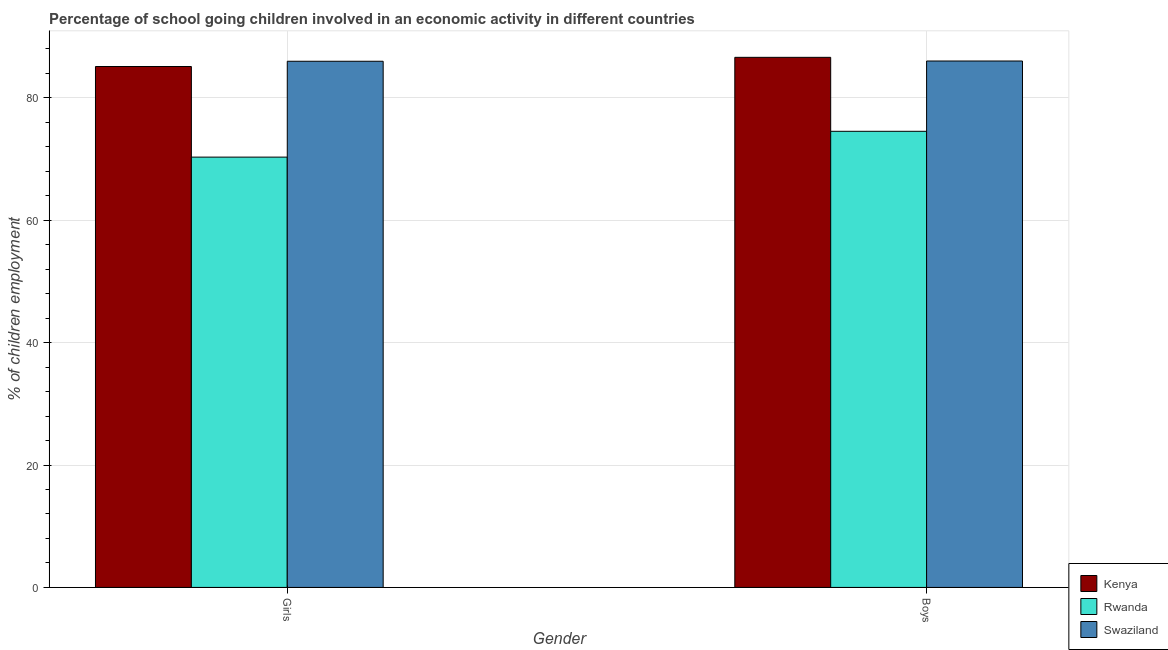How many different coloured bars are there?
Provide a succinct answer. 3. How many groups of bars are there?
Make the answer very short. 2. Are the number of bars per tick equal to the number of legend labels?
Offer a terse response. Yes. How many bars are there on the 1st tick from the left?
Your response must be concise. 3. How many bars are there on the 1st tick from the right?
Keep it short and to the point. 3. What is the label of the 2nd group of bars from the left?
Make the answer very short. Boys. What is the percentage of school going girls in Rwanda?
Offer a terse response. 70.3. Across all countries, what is the maximum percentage of school going girls?
Your response must be concise. 85.96. Across all countries, what is the minimum percentage of school going boys?
Provide a succinct answer. 74.52. In which country was the percentage of school going girls maximum?
Your answer should be compact. Swaziland. In which country was the percentage of school going girls minimum?
Offer a terse response. Rwanda. What is the total percentage of school going girls in the graph?
Make the answer very short. 241.36. What is the difference between the percentage of school going boys in Kenya and that in Swaziland?
Give a very brief answer. 0.6. What is the difference between the percentage of school going girls in Swaziland and the percentage of school going boys in Kenya?
Keep it short and to the point. -0.64. What is the average percentage of school going girls per country?
Make the answer very short. 80.45. What is the difference between the percentage of school going boys and percentage of school going girls in Swaziland?
Provide a short and direct response. 0.04. In how many countries, is the percentage of school going boys greater than 84 %?
Your answer should be compact. 2. What is the ratio of the percentage of school going boys in Kenya to that in Rwanda?
Ensure brevity in your answer.  1.16. In how many countries, is the percentage of school going boys greater than the average percentage of school going boys taken over all countries?
Keep it short and to the point. 2. What does the 1st bar from the left in Boys represents?
Keep it short and to the point. Kenya. What does the 1st bar from the right in Boys represents?
Offer a very short reply. Swaziland. How many bars are there?
Your answer should be very brief. 6. Are all the bars in the graph horizontal?
Your answer should be very brief. No. How many countries are there in the graph?
Make the answer very short. 3. What is the difference between two consecutive major ticks on the Y-axis?
Provide a short and direct response. 20. Does the graph contain any zero values?
Offer a very short reply. No. Does the graph contain grids?
Provide a short and direct response. Yes. How are the legend labels stacked?
Give a very brief answer. Vertical. What is the title of the graph?
Your response must be concise. Percentage of school going children involved in an economic activity in different countries. What is the label or title of the X-axis?
Make the answer very short. Gender. What is the label or title of the Y-axis?
Offer a very short reply. % of children employment. What is the % of children employment in Kenya in Girls?
Ensure brevity in your answer.  85.1. What is the % of children employment in Rwanda in Girls?
Offer a very short reply. 70.3. What is the % of children employment of Swaziland in Girls?
Your answer should be compact. 85.96. What is the % of children employment in Kenya in Boys?
Your response must be concise. 86.6. What is the % of children employment in Rwanda in Boys?
Offer a terse response. 74.52. What is the % of children employment in Swaziland in Boys?
Ensure brevity in your answer.  86. Across all Gender, what is the maximum % of children employment in Kenya?
Offer a terse response. 86.6. Across all Gender, what is the maximum % of children employment in Rwanda?
Give a very brief answer. 74.52. Across all Gender, what is the maximum % of children employment of Swaziland?
Give a very brief answer. 86. Across all Gender, what is the minimum % of children employment in Kenya?
Your answer should be compact. 85.1. Across all Gender, what is the minimum % of children employment in Rwanda?
Your answer should be compact. 70.3. Across all Gender, what is the minimum % of children employment of Swaziland?
Provide a succinct answer. 85.96. What is the total % of children employment in Kenya in the graph?
Give a very brief answer. 171.7. What is the total % of children employment in Rwanda in the graph?
Your answer should be very brief. 144.81. What is the total % of children employment in Swaziland in the graph?
Ensure brevity in your answer.  171.96. What is the difference between the % of children employment of Kenya in Girls and that in Boys?
Give a very brief answer. -1.5. What is the difference between the % of children employment in Rwanda in Girls and that in Boys?
Give a very brief answer. -4.22. What is the difference between the % of children employment of Swaziland in Girls and that in Boys?
Your answer should be compact. -0.04. What is the difference between the % of children employment in Kenya in Girls and the % of children employment in Rwanda in Boys?
Your response must be concise. 10.58. What is the difference between the % of children employment in Kenya in Girls and the % of children employment in Swaziland in Boys?
Offer a very short reply. -0.9. What is the difference between the % of children employment in Rwanda in Girls and the % of children employment in Swaziland in Boys?
Keep it short and to the point. -15.7. What is the average % of children employment in Kenya per Gender?
Offer a very short reply. 85.85. What is the average % of children employment in Rwanda per Gender?
Keep it short and to the point. 72.41. What is the average % of children employment in Swaziland per Gender?
Offer a terse response. 85.98. What is the difference between the % of children employment in Kenya and % of children employment in Rwanda in Girls?
Make the answer very short. 14.8. What is the difference between the % of children employment of Kenya and % of children employment of Swaziland in Girls?
Give a very brief answer. -0.86. What is the difference between the % of children employment in Rwanda and % of children employment in Swaziland in Girls?
Your answer should be compact. -15.66. What is the difference between the % of children employment in Kenya and % of children employment in Rwanda in Boys?
Make the answer very short. 12.08. What is the difference between the % of children employment in Kenya and % of children employment in Swaziland in Boys?
Keep it short and to the point. 0.6. What is the difference between the % of children employment of Rwanda and % of children employment of Swaziland in Boys?
Your answer should be compact. -11.48. What is the ratio of the % of children employment of Kenya in Girls to that in Boys?
Provide a short and direct response. 0.98. What is the ratio of the % of children employment of Rwanda in Girls to that in Boys?
Provide a succinct answer. 0.94. What is the ratio of the % of children employment of Swaziland in Girls to that in Boys?
Give a very brief answer. 1. What is the difference between the highest and the second highest % of children employment of Rwanda?
Make the answer very short. 4.22. What is the difference between the highest and the second highest % of children employment of Swaziland?
Your response must be concise. 0.04. What is the difference between the highest and the lowest % of children employment in Kenya?
Make the answer very short. 1.5. What is the difference between the highest and the lowest % of children employment in Rwanda?
Give a very brief answer. 4.22. What is the difference between the highest and the lowest % of children employment in Swaziland?
Your answer should be very brief. 0.04. 